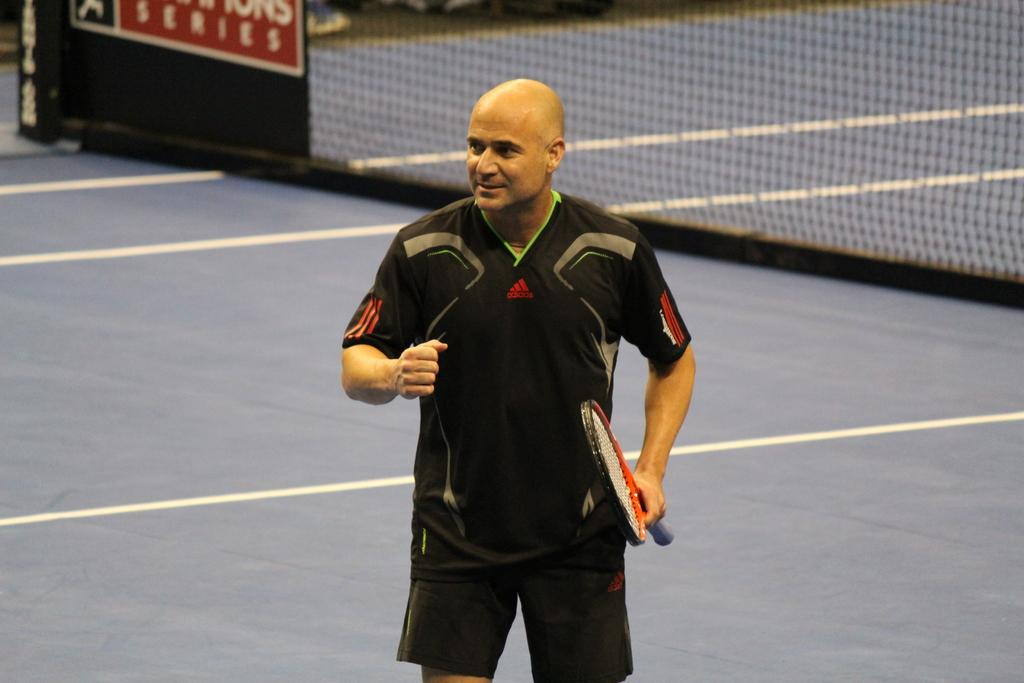Who is present in the image? There is a man in the image. What is the man doing in the image? The man is standing in the image. What object is the man holding in the image? The man is holding a racket in the image. What type of clothing is the man wearing in the image? The man is wearing sports wear in the image. What type of cherry is the man eating in the image? There is no cherry present in the image; the man is holding a racket and wearing sports wear. 